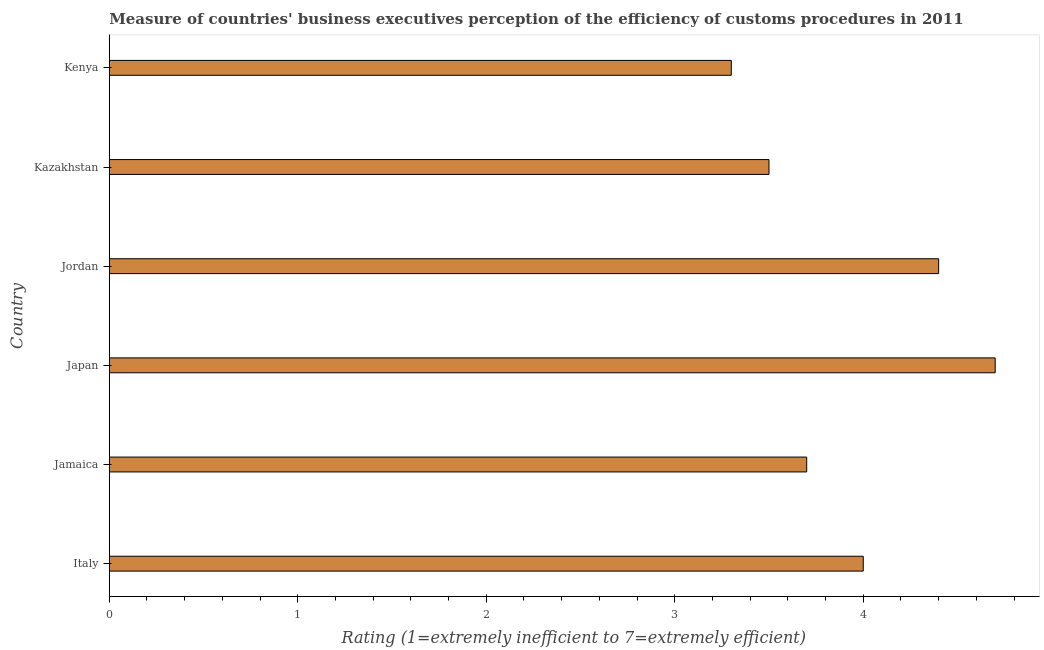Does the graph contain grids?
Offer a terse response. No. What is the title of the graph?
Your answer should be compact. Measure of countries' business executives perception of the efficiency of customs procedures in 2011. What is the label or title of the X-axis?
Offer a very short reply. Rating (1=extremely inefficient to 7=extremely efficient). What is the rating measuring burden of customs procedure in Jamaica?
Your answer should be very brief. 3.7. Across all countries, what is the maximum rating measuring burden of customs procedure?
Your answer should be compact. 4.7. In which country was the rating measuring burden of customs procedure minimum?
Ensure brevity in your answer.  Kenya. What is the sum of the rating measuring burden of customs procedure?
Offer a very short reply. 23.6. What is the average rating measuring burden of customs procedure per country?
Provide a short and direct response. 3.93. What is the median rating measuring burden of customs procedure?
Ensure brevity in your answer.  3.85. What is the ratio of the rating measuring burden of customs procedure in Italy to that in Jordan?
Provide a succinct answer. 0.91. Is the sum of the rating measuring burden of customs procedure in Jamaica and Kenya greater than the maximum rating measuring burden of customs procedure across all countries?
Your answer should be compact. Yes. Are all the bars in the graph horizontal?
Give a very brief answer. Yes. What is the difference between two consecutive major ticks on the X-axis?
Offer a very short reply. 1. What is the Rating (1=extremely inefficient to 7=extremely efficient) of Kazakhstan?
Provide a succinct answer. 3.5. What is the difference between the Rating (1=extremely inefficient to 7=extremely efficient) in Italy and Jamaica?
Your answer should be very brief. 0.3. What is the difference between the Rating (1=extremely inefficient to 7=extremely efficient) in Italy and Japan?
Ensure brevity in your answer.  -0.7. What is the difference between the Rating (1=extremely inefficient to 7=extremely efficient) in Italy and Jordan?
Ensure brevity in your answer.  -0.4. What is the difference between the Rating (1=extremely inefficient to 7=extremely efficient) in Italy and Kazakhstan?
Give a very brief answer. 0.5. What is the difference between the Rating (1=extremely inefficient to 7=extremely efficient) in Italy and Kenya?
Give a very brief answer. 0.7. What is the difference between the Rating (1=extremely inefficient to 7=extremely efficient) in Jamaica and Jordan?
Ensure brevity in your answer.  -0.7. What is the difference between the Rating (1=extremely inefficient to 7=extremely efficient) in Jamaica and Kenya?
Offer a terse response. 0.4. What is the difference between the Rating (1=extremely inefficient to 7=extremely efficient) in Japan and Jordan?
Keep it short and to the point. 0.3. What is the difference between the Rating (1=extremely inefficient to 7=extremely efficient) in Jordan and Kenya?
Provide a short and direct response. 1.1. What is the difference between the Rating (1=extremely inefficient to 7=extremely efficient) in Kazakhstan and Kenya?
Keep it short and to the point. 0.2. What is the ratio of the Rating (1=extremely inefficient to 7=extremely efficient) in Italy to that in Jamaica?
Keep it short and to the point. 1.08. What is the ratio of the Rating (1=extremely inefficient to 7=extremely efficient) in Italy to that in Japan?
Give a very brief answer. 0.85. What is the ratio of the Rating (1=extremely inefficient to 7=extremely efficient) in Italy to that in Jordan?
Offer a terse response. 0.91. What is the ratio of the Rating (1=extremely inefficient to 7=extremely efficient) in Italy to that in Kazakhstan?
Make the answer very short. 1.14. What is the ratio of the Rating (1=extremely inefficient to 7=extremely efficient) in Italy to that in Kenya?
Make the answer very short. 1.21. What is the ratio of the Rating (1=extremely inefficient to 7=extremely efficient) in Jamaica to that in Japan?
Your answer should be compact. 0.79. What is the ratio of the Rating (1=extremely inefficient to 7=extremely efficient) in Jamaica to that in Jordan?
Ensure brevity in your answer.  0.84. What is the ratio of the Rating (1=extremely inefficient to 7=extremely efficient) in Jamaica to that in Kazakhstan?
Keep it short and to the point. 1.06. What is the ratio of the Rating (1=extremely inefficient to 7=extremely efficient) in Jamaica to that in Kenya?
Your response must be concise. 1.12. What is the ratio of the Rating (1=extremely inefficient to 7=extremely efficient) in Japan to that in Jordan?
Offer a very short reply. 1.07. What is the ratio of the Rating (1=extremely inefficient to 7=extremely efficient) in Japan to that in Kazakhstan?
Offer a terse response. 1.34. What is the ratio of the Rating (1=extremely inefficient to 7=extremely efficient) in Japan to that in Kenya?
Your answer should be compact. 1.42. What is the ratio of the Rating (1=extremely inefficient to 7=extremely efficient) in Jordan to that in Kazakhstan?
Your answer should be very brief. 1.26. What is the ratio of the Rating (1=extremely inefficient to 7=extremely efficient) in Jordan to that in Kenya?
Keep it short and to the point. 1.33. What is the ratio of the Rating (1=extremely inefficient to 7=extremely efficient) in Kazakhstan to that in Kenya?
Provide a short and direct response. 1.06. 